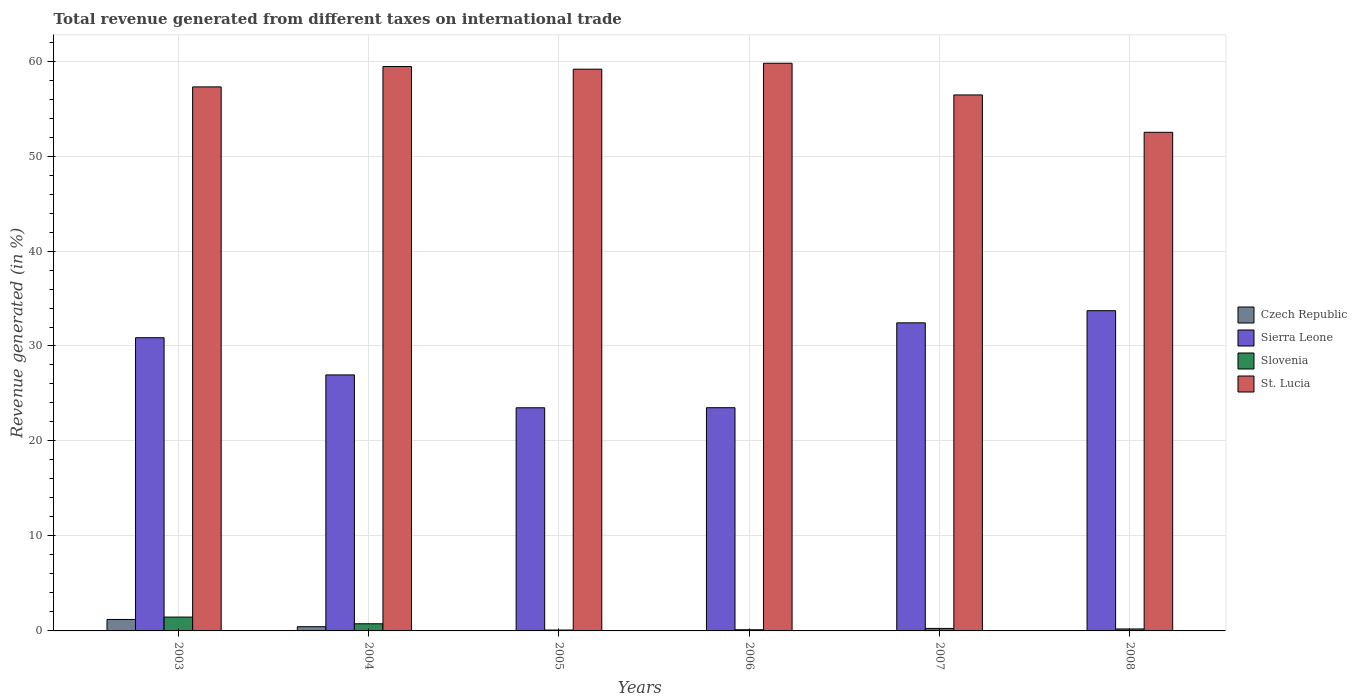Are the number of bars per tick equal to the number of legend labels?
Provide a short and direct response. No. What is the total revenue generated in Sierra Leone in 2006?
Ensure brevity in your answer.  23.5. Across all years, what is the maximum total revenue generated in Slovenia?
Keep it short and to the point. 1.46. In which year was the total revenue generated in Sierra Leone maximum?
Your response must be concise. 2008. What is the total total revenue generated in Slovenia in the graph?
Make the answer very short. 2.9. What is the difference between the total revenue generated in St. Lucia in 2004 and that in 2008?
Ensure brevity in your answer.  6.92. What is the difference between the total revenue generated in Sierra Leone in 2008 and the total revenue generated in Czech Republic in 2003?
Your answer should be very brief. 32.51. What is the average total revenue generated in Czech Republic per year?
Your answer should be compact. 0.28. In the year 2008, what is the difference between the total revenue generated in Sierra Leone and total revenue generated in Slovenia?
Give a very brief answer. 33.51. In how many years, is the total revenue generated in Czech Republic greater than 46 %?
Provide a short and direct response. 0. What is the ratio of the total revenue generated in St. Lucia in 2004 to that in 2005?
Provide a short and direct response. 1. Is the total revenue generated in Slovenia in 2003 less than that in 2006?
Your response must be concise. No. Is the difference between the total revenue generated in Sierra Leone in 2003 and 2004 greater than the difference between the total revenue generated in Slovenia in 2003 and 2004?
Your answer should be very brief. Yes. What is the difference between the highest and the second highest total revenue generated in Sierra Leone?
Ensure brevity in your answer.  1.28. What is the difference between the highest and the lowest total revenue generated in Slovenia?
Give a very brief answer. 1.36. Is the sum of the total revenue generated in Sierra Leone in 2003 and 2006 greater than the maximum total revenue generated in Czech Republic across all years?
Your answer should be compact. Yes. Is it the case that in every year, the sum of the total revenue generated in St. Lucia and total revenue generated in Slovenia is greater than the sum of total revenue generated in Sierra Leone and total revenue generated in Czech Republic?
Offer a terse response. Yes. Is it the case that in every year, the sum of the total revenue generated in St. Lucia and total revenue generated in Sierra Leone is greater than the total revenue generated in Czech Republic?
Give a very brief answer. Yes. How many years are there in the graph?
Ensure brevity in your answer.  6. Does the graph contain any zero values?
Keep it short and to the point. Yes. Does the graph contain grids?
Keep it short and to the point. Yes. What is the title of the graph?
Ensure brevity in your answer.  Total revenue generated from different taxes on international trade. Does "Tonga" appear as one of the legend labels in the graph?
Make the answer very short. No. What is the label or title of the X-axis?
Your answer should be very brief. Years. What is the label or title of the Y-axis?
Make the answer very short. Revenue generated (in %). What is the Revenue generated (in %) of Czech Republic in 2003?
Ensure brevity in your answer.  1.21. What is the Revenue generated (in %) in Sierra Leone in 2003?
Provide a succinct answer. 30.87. What is the Revenue generated (in %) of Slovenia in 2003?
Your response must be concise. 1.46. What is the Revenue generated (in %) in St. Lucia in 2003?
Make the answer very short. 57.28. What is the Revenue generated (in %) of Czech Republic in 2004?
Your answer should be compact. 0.45. What is the Revenue generated (in %) of Sierra Leone in 2004?
Offer a very short reply. 26.96. What is the Revenue generated (in %) in Slovenia in 2004?
Give a very brief answer. 0.75. What is the Revenue generated (in %) of St. Lucia in 2004?
Provide a succinct answer. 59.42. What is the Revenue generated (in %) in Czech Republic in 2005?
Provide a succinct answer. 0. What is the Revenue generated (in %) in Sierra Leone in 2005?
Give a very brief answer. 23.5. What is the Revenue generated (in %) in Slovenia in 2005?
Give a very brief answer. 0.09. What is the Revenue generated (in %) in St. Lucia in 2005?
Offer a terse response. 59.15. What is the Revenue generated (in %) in Czech Republic in 2006?
Your answer should be compact. 0. What is the Revenue generated (in %) of Sierra Leone in 2006?
Offer a very short reply. 23.5. What is the Revenue generated (in %) of Slovenia in 2006?
Provide a short and direct response. 0.12. What is the Revenue generated (in %) in St. Lucia in 2006?
Offer a terse response. 59.77. What is the Revenue generated (in %) in Czech Republic in 2007?
Give a very brief answer. 0. What is the Revenue generated (in %) of Sierra Leone in 2007?
Ensure brevity in your answer.  32.44. What is the Revenue generated (in %) of Slovenia in 2007?
Your response must be concise. 0.26. What is the Revenue generated (in %) in St. Lucia in 2007?
Keep it short and to the point. 56.43. What is the Revenue generated (in %) in Czech Republic in 2008?
Make the answer very short. 0. What is the Revenue generated (in %) in Sierra Leone in 2008?
Give a very brief answer. 33.72. What is the Revenue generated (in %) of Slovenia in 2008?
Give a very brief answer. 0.21. What is the Revenue generated (in %) of St. Lucia in 2008?
Give a very brief answer. 52.5. Across all years, what is the maximum Revenue generated (in %) of Czech Republic?
Offer a very short reply. 1.21. Across all years, what is the maximum Revenue generated (in %) in Sierra Leone?
Your answer should be compact. 33.72. Across all years, what is the maximum Revenue generated (in %) of Slovenia?
Make the answer very short. 1.46. Across all years, what is the maximum Revenue generated (in %) of St. Lucia?
Provide a succinct answer. 59.77. Across all years, what is the minimum Revenue generated (in %) of Czech Republic?
Your answer should be very brief. 0. Across all years, what is the minimum Revenue generated (in %) in Sierra Leone?
Ensure brevity in your answer.  23.5. Across all years, what is the minimum Revenue generated (in %) of Slovenia?
Offer a very short reply. 0.09. Across all years, what is the minimum Revenue generated (in %) in St. Lucia?
Your response must be concise. 52.5. What is the total Revenue generated (in %) of Czech Republic in the graph?
Your answer should be very brief. 1.66. What is the total Revenue generated (in %) in Sierra Leone in the graph?
Offer a very short reply. 170.98. What is the total Revenue generated (in %) of Slovenia in the graph?
Give a very brief answer. 2.9. What is the total Revenue generated (in %) in St. Lucia in the graph?
Ensure brevity in your answer.  344.55. What is the difference between the Revenue generated (in %) in Czech Republic in 2003 and that in 2004?
Give a very brief answer. 0.76. What is the difference between the Revenue generated (in %) of Sierra Leone in 2003 and that in 2004?
Keep it short and to the point. 3.92. What is the difference between the Revenue generated (in %) in Slovenia in 2003 and that in 2004?
Give a very brief answer. 0.7. What is the difference between the Revenue generated (in %) in St. Lucia in 2003 and that in 2004?
Offer a terse response. -2.14. What is the difference between the Revenue generated (in %) of Sierra Leone in 2003 and that in 2005?
Offer a terse response. 7.38. What is the difference between the Revenue generated (in %) in Slovenia in 2003 and that in 2005?
Offer a very short reply. 1.36. What is the difference between the Revenue generated (in %) of St. Lucia in 2003 and that in 2005?
Offer a very short reply. -1.87. What is the difference between the Revenue generated (in %) in Czech Republic in 2003 and that in 2006?
Make the answer very short. 1.21. What is the difference between the Revenue generated (in %) in Sierra Leone in 2003 and that in 2006?
Offer a terse response. 7.37. What is the difference between the Revenue generated (in %) of Slovenia in 2003 and that in 2006?
Keep it short and to the point. 1.33. What is the difference between the Revenue generated (in %) in St. Lucia in 2003 and that in 2006?
Your answer should be very brief. -2.49. What is the difference between the Revenue generated (in %) of Czech Republic in 2003 and that in 2007?
Provide a short and direct response. 1.21. What is the difference between the Revenue generated (in %) of Sierra Leone in 2003 and that in 2007?
Offer a terse response. -1.57. What is the difference between the Revenue generated (in %) in Slovenia in 2003 and that in 2007?
Your answer should be compact. 1.19. What is the difference between the Revenue generated (in %) of St. Lucia in 2003 and that in 2007?
Keep it short and to the point. 0.85. What is the difference between the Revenue generated (in %) in Czech Republic in 2003 and that in 2008?
Your answer should be very brief. 1.21. What is the difference between the Revenue generated (in %) of Sierra Leone in 2003 and that in 2008?
Offer a very short reply. -2.85. What is the difference between the Revenue generated (in %) of Slovenia in 2003 and that in 2008?
Provide a short and direct response. 1.25. What is the difference between the Revenue generated (in %) of St. Lucia in 2003 and that in 2008?
Your answer should be very brief. 4.78. What is the difference between the Revenue generated (in %) of Sierra Leone in 2004 and that in 2005?
Ensure brevity in your answer.  3.46. What is the difference between the Revenue generated (in %) of Slovenia in 2004 and that in 2005?
Your answer should be compact. 0.66. What is the difference between the Revenue generated (in %) of St. Lucia in 2004 and that in 2005?
Ensure brevity in your answer.  0.28. What is the difference between the Revenue generated (in %) of Czech Republic in 2004 and that in 2006?
Make the answer very short. 0.44. What is the difference between the Revenue generated (in %) in Sierra Leone in 2004 and that in 2006?
Your response must be concise. 3.45. What is the difference between the Revenue generated (in %) in Slovenia in 2004 and that in 2006?
Make the answer very short. 0.63. What is the difference between the Revenue generated (in %) of St. Lucia in 2004 and that in 2006?
Give a very brief answer. -0.35. What is the difference between the Revenue generated (in %) of Czech Republic in 2004 and that in 2007?
Make the answer very short. 0.44. What is the difference between the Revenue generated (in %) of Sierra Leone in 2004 and that in 2007?
Offer a terse response. -5.48. What is the difference between the Revenue generated (in %) of Slovenia in 2004 and that in 2007?
Provide a short and direct response. 0.49. What is the difference between the Revenue generated (in %) in St. Lucia in 2004 and that in 2007?
Provide a short and direct response. 2.99. What is the difference between the Revenue generated (in %) in Czech Republic in 2004 and that in 2008?
Provide a short and direct response. 0.44. What is the difference between the Revenue generated (in %) of Sierra Leone in 2004 and that in 2008?
Your response must be concise. -6.76. What is the difference between the Revenue generated (in %) of Slovenia in 2004 and that in 2008?
Keep it short and to the point. 0.55. What is the difference between the Revenue generated (in %) of St. Lucia in 2004 and that in 2008?
Your answer should be very brief. 6.92. What is the difference between the Revenue generated (in %) in Sierra Leone in 2005 and that in 2006?
Keep it short and to the point. -0.01. What is the difference between the Revenue generated (in %) in Slovenia in 2005 and that in 2006?
Your answer should be compact. -0.03. What is the difference between the Revenue generated (in %) in St. Lucia in 2005 and that in 2006?
Your answer should be very brief. -0.62. What is the difference between the Revenue generated (in %) in Sierra Leone in 2005 and that in 2007?
Offer a terse response. -8.94. What is the difference between the Revenue generated (in %) of Slovenia in 2005 and that in 2007?
Ensure brevity in your answer.  -0.17. What is the difference between the Revenue generated (in %) in St. Lucia in 2005 and that in 2007?
Provide a succinct answer. 2.71. What is the difference between the Revenue generated (in %) of Sierra Leone in 2005 and that in 2008?
Provide a succinct answer. -10.22. What is the difference between the Revenue generated (in %) in Slovenia in 2005 and that in 2008?
Make the answer very short. -0.11. What is the difference between the Revenue generated (in %) in St. Lucia in 2005 and that in 2008?
Your response must be concise. 6.65. What is the difference between the Revenue generated (in %) in Czech Republic in 2006 and that in 2007?
Ensure brevity in your answer.  -0. What is the difference between the Revenue generated (in %) of Sierra Leone in 2006 and that in 2007?
Provide a succinct answer. -8.94. What is the difference between the Revenue generated (in %) in Slovenia in 2006 and that in 2007?
Your response must be concise. -0.14. What is the difference between the Revenue generated (in %) in St. Lucia in 2006 and that in 2007?
Provide a short and direct response. 3.34. What is the difference between the Revenue generated (in %) in Czech Republic in 2006 and that in 2008?
Ensure brevity in your answer.  -0. What is the difference between the Revenue generated (in %) in Sierra Leone in 2006 and that in 2008?
Keep it short and to the point. -10.21. What is the difference between the Revenue generated (in %) in Slovenia in 2006 and that in 2008?
Give a very brief answer. -0.08. What is the difference between the Revenue generated (in %) of St. Lucia in 2006 and that in 2008?
Provide a short and direct response. 7.27. What is the difference between the Revenue generated (in %) of Czech Republic in 2007 and that in 2008?
Offer a terse response. 0. What is the difference between the Revenue generated (in %) of Sierra Leone in 2007 and that in 2008?
Your answer should be compact. -1.28. What is the difference between the Revenue generated (in %) in Slovenia in 2007 and that in 2008?
Make the answer very short. 0.06. What is the difference between the Revenue generated (in %) in St. Lucia in 2007 and that in 2008?
Offer a terse response. 3.93. What is the difference between the Revenue generated (in %) of Czech Republic in 2003 and the Revenue generated (in %) of Sierra Leone in 2004?
Provide a short and direct response. -25.75. What is the difference between the Revenue generated (in %) in Czech Republic in 2003 and the Revenue generated (in %) in Slovenia in 2004?
Make the answer very short. 0.45. What is the difference between the Revenue generated (in %) of Czech Republic in 2003 and the Revenue generated (in %) of St. Lucia in 2004?
Your response must be concise. -58.22. What is the difference between the Revenue generated (in %) of Sierra Leone in 2003 and the Revenue generated (in %) of Slovenia in 2004?
Your answer should be compact. 30.12. What is the difference between the Revenue generated (in %) in Sierra Leone in 2003 and the Revenue generated (in %) in St. Lucia in 2004?
Your answer should be very brief. -28.55. What is the difference between the Revenue generated (in %) in Slovenia in 2003 and the Revenue generated (in %) in St. Lucia in 2004?
Your answer should be very brief. -57.96. What is the difference between the Revenue generated (in %) of Czech Republic in 2003 and the Revenue generated (in %) of Sierra Leone in 2005?
Your answer should be very brief. -22.29. What is the difference between the Revenue generated (in %) in Czech Republic in 2003 and the Revenue generated (in %) in Slovenia in 2005?
Your answer should be very brief. 1.11. What is the difference between the Revenue generated (in %) in Czech Republic in 2003 and the Revenue generated (in %) in St. Lucia in 2005?
Your answer should be very brief. -57.94. What is the difference between the Revenue generated (in %) in Sierra Leone in 2003 and the Revenue generated (in %) in Slovenia in 2005?
Make the answer very short. 30.78. What is the difference between the Revenue generated (in %) of Sierra Leone in 2003 and the Revenue generated (in %) of St. Lucia in 2005?
Keep it short and to the point. -28.28. What is the difference between the Revenue generated (in %) in Slovenia in 2003 and the Revenue generated (in %) in St. Lucia in 2005?
Your response must be concise. -57.69. What is the difference between the Revenue generated (in %) in Czech Republic in 2003 and the Revenue generated (in %) in Sierra Leone in 2006?
Offer a very short reply. -22.3. What is the difference between the Revenue generated (in %) in Czech Republic in 2003 and the Revenue generated (in %) in Slovenia in 2006?
Ensure brevity in your answer.  1.08. What is the difference between the Revenue generated (in %) of Czech Republic in 2003 and the Revenue generated (in %) of St. Lucia in 2006?
Provide a short and direct response. -58.56. What is the difference between the Revenue generated (in %) in Sierra Leone in 2003 and the Revenue generated (in %) in Slovenia in 2006?
Your answer should be compact. 30.75. What is the difference between the Revenue generated (in %) of Sierra Leone in 2003 and the Revenue generated (in %) of St. Lucia in 2006?
Your response must be concise. -28.9. What is the difference between the Revenue generated (in %) of Slovenia in 2003 and the Revenue generated (in %) of St. Lucia in 2006?
Provide a succinct answer. -58.31. What is the difference between the Revenue generated (in %) in Czech Republic in 2003 and the Revenue generated (in %) in Sierra Leone in 2007?
Your answer should be very brief. -31.23. What is the difference between the Revenue generated (in %) in Czech Republic in 2003 and the Revenue generated (in %) in Slovenia in 2007?
Offer a very short reply. 0.94. What is the difference between the Revenue generated (in %) of Czech Republic in 2003 and the Revenue generated (in %) of St. Lucia in 2007?
Provide a succinct answer. -55.23. What is the difference between the Revenue generated (in %) in Sierra Leone in 2003 and the Revenue generated (in %) in Slovenia in 2007?
Ensure brevity in your answer.  30.61. What is the difference between the Revenue generated (in %) in Sierra Leone in 2003 and the Revenue generated (in %) in St. Lucia in 2007?
Give a very brief answer. -25.56. What is the difference between the Revenue generated (in %) of Slovenia in 2003 and the Revenue generated (in %) of St. Lucia in 2007?
Keep it short and to the point. -54.98. What is the difference between the Revenue generated (in %) in Czech Republic in 2003 and the Revenue generated (in %) in Sierra Leone in 2008?
Provide a succinct answer. -32.51. What is the difference between the Revenue generated (in %) of Czech Republic in 2003 and the Revenue generated (in %) of Slovenia in 2008?
Your answer should be very brief. 1. What is the difference between the Revenue generated (in %) in Czech Republic in 2003 and the Revenue generated (in %) in St. Lucia in 2008?
Offer a terse response. -51.29. What is the difference between the Revenue generated (in %) of Sierra Leone in 2003 and the Revenue generated (in %) of Slovenia in 2008?
Make the answer very short. 30.66. What is the difference between the Revenue generated (in %) of Sierra Leone in 2003 and the Revenue generated (in %) of St. Lucia in 2008?
Your answer should be very brief. -21.63. What is the difference between the Revenue generated (in %) of Slovenia in 2003 and the Revenue generated (in %) of St. Lucia in 2008?
Your response must be concise. -51.04. What is the difference between the Revenue generated (in %) in Czech Republic in 2004 and the Revenue generated (in %) in Sierra Leone in 2005?
Give a very brief answer. -23.05. What is the difference between the Revenue generated (in %) of Czech Republic in 2004 and the Revenue generated (in %) of Slovenia in 2005?
Offer a very short reply. 0.35. What is the difference between the Revenue generated (in %) of Czech Republic in 2004 and the Revenue generated (in %) of St. Lucia in 2005?
Your answer should be very brief. -58.7. What is the difference between the Revenue generated (in %) of Sierra Leone in 2004 and the Revenue generated (in %) of Slovenia in 2005?
Make the answer very short. 26.86. What is the difference between the Revenue generated (in %) of Sierra Leone in 2004 and the Revenue generated (in %) of St. Lucia in 2005?
Your answer should be compact. -32.19. What is the difference between the Revenue generated (in %) in Slovenia in 2004 and the Revenue generated (in %) in St. Lucia in 2005?
Give a very brief answer. -58.39. What is the difference between the Revenue generated (in %) in Czech Republic in 2004 and the Revenue generated (in %) in Sierra Leone in 2006?
Your response must be concise. -23.06. What is the difference between the Revenue generated (in %) of Czech Republic in 2004 and the Revenue generated (in %) of Slovenia in 2006?
Keep it short and to the point. 0.32. What is the difference between the Revenue generated (in %) of Czech Republic in 2004 and the Revenue generated (in %) of St. Lucia in 2006?
Provide a short and direct response. -59.32. What is the difference between the Revenue generated (in %) of Sierra Leone in 2004 and the Revenue generated (in %) of Slovenia in 2006?
Offer a terse response. 26.83. What is the difference between the Revenue generated (in %) of Sierra Leone in 2004 and the Revenue generated (in %) of St. Lucia in 2006?
Provide a short and direct response. -32.81. What is the difference between the Revenue generated (in %) in Slovenia in 2004 and the Revenue generated (in %) in St. Lucia in 2006?
Your response must be concise. -59.02. What is the difference between the Revenue generated (in %) of Czech Republic in 2004 and the Revenue generated (in %) of Sierra Leone in 2007?
Your answer should be compact. -31.99. What is the difference between the Revenue generated (in %) in Czech Republic in 2004 and the Revenue generated (in %) in Slovenia in 2007?
Make the answer very short. 0.18. What is the difference between the Revenue generated (in %) in Czech Republic in 2004 and the Revenue generated (in %) in St. Lucia in 2007?
Your response must be concise. -55.99. What is the difference between the Revenue generated (in %) in Sierra Leone in 2004 and the Revenue generated (in %) in Slovenia in 2007?
Your answer should be compact. 26.69. What is the difference between the Revenue generated (in %) of Sierra Leone in 2004 and the Revenue generated (in %) of St. Lucia in 2007?
Your answer should be compact. -29.48. What is the difference between the Revenue generated (in %) of Slovenia in 2004 and the Revenue generated (in %) of St. Lucia in 2007?
Your answer should be very brief. -55.68. What is the difference between the Revenue generated (in %) in Czech Republic in 2004 and the Revenue generated (in %) in Sierra Leone in 2008?
Ensure brevity in your answer.  -33.27. What is the difference between the Revenue generated (in %) of Czech Republic in 2004 and the Revenue generated (in %) of Slovenia in 2008?
Offer a terse response. 0.24. What is the difference between the Revenue generated (in %) in Czech Republic in 2004 and the Revenue generated (in %) in St. Lucia in 2008?
Keep it short and to the point. -52.05. What is the difference between the Revenue generated (in %) of Sierra Leone in 2004 and the Revenue generated (in %) of Slovenia in 2008?
Keep it short and to the point. 26.75. What is the difference between the Revenue generated (in %) in Sierra Leone in 2004 and the Revenue generated (in %) in St. Lucia in 2008?
Give a very brief answer. -25.55. What is the difference between the Revenue generated (in %) in Slovenia in 2004 and the Revenue generated (in %) in St. Lucia in 2008?
Ensure brevity in your answer.  -51.75. What is the difference between the Revenue generated (in %) of Sierra Leone in 2005 and the Revenue generated (in %) of Slovenia in 2006?
Offer a terse response. 23.37. What is the difference between the Revenue generated (in %) of Sierra Leone in 2005 and the Revenue generated (in %) of St. Lucia in 2006?
Provide a succinct answer. -36.27. What is the difference between the Revenue generated (in %) of Slovenia in 2005 and the Revenue generated (in %) of St. Lucia in 2006?
Your response must be concise. -59.68. What is the difference between the Revenue generated (in %) in Sierra Leone in 2005 and the Revenue generated (in %) in Slovenia in 2007?
Make the answer very short. 23.23. What is the difference between the Revenue generated (in %) of Sierra Leone in 2005 and the Revenue generated (in %) of St. Lucia in 2007?
Your response must be concise. -32.94. What is the difference between the Revenue generated (in %) in Slovenia in 2005 and the Revenue generated (in %) in St. Lucia in 2007?
Ensure brevity in your answer.  -56.34. What is the difference between the Revenue generated (in %) of Sierra Leone in 2005 and the Revenue generated (in %) of Slovenia in 2008?
Your response must be concise. 23.29. What is the difference between the Revenue generated (in %) in Sierra Leone in 2005 and the Revenue generated (in %) in St. Lucia in 2008?
Offer a very short reply. -29. What is the difference between the Revenue generated (in %) in Slovenia in 2005 and the Revenue generated (in %) in St. Lucia in 2008?
Give a very brief answer. -52.41. What is the difference between the Revenue generated (in %) in Czech Republic in 2006 and the Revenue generated (in %) in Sierra Leone in 2007?
Your answer should be compact. -32.44. What is the difference between the Revenue generated (in %) in Czech Republic in 2006 and the Revenue generated (in %) in Slovenia in 2007?
Provide a short and direct response. -0.26. What is the difference between the Revenue generated (in %) of Czech Republic in 2006 and the Revenue generated (in %) of St. Lucia in 2007?
Your response must be concise. -56.43. What is the difference between the Revenue generated (in %) in Sierra Leone in 2006 and the Revenue generated (in %) in Slovenia in 2007?
Ensure brevity in your answer.  23.24. What is the difference between the Revenue generated (in %) in Sierra Leone in 2006 and the Revenue generated (in %) in St. Lucia in 2007?
Your answer should be compact. -32.93. What is the difference between the Revenue generated (in %) in Slovenia in 2006 and the Revenue generated (in %) in St. Lucia in 2007?
Provide a short and direct response. -56.31. What is the difference between the Revenue generated (in %) in Czech Republic in 2006 and the Revenue generated (in %) in Sierra Leone in 2008?
Ensure brevity in your answer.  -33.72. What is the difference between the Revenue generated (in %) in Czech Republic in 2006 and the Revenue generated (in %) in Slovenia in 2008?
Keep it short and to the point. -0.21. What is the difference between the Revenue generated (in %) in Czech Republic in 2006 and the Revenue generated (in %) in St. Lucia in 2008?
Offer a very short reply. -52.5. What is the difference between the Revenue generated (in %) of Sierra Leone in 2006 and the Revenue generated (in %) of Slovenia in 2008?
Ensure brevity in your answer.  23.3. What is the difference between the Revenue generated (in %) in Sierra Leone in 2006 and the Revenue generated (in %) in St. Lucia in 2008?
Give a very brief answer. -29. What is the difference between the Revenue generated (in %) of Slovenia in 2006 and the Revenue generated (in %) of St. Lucia in 2008?
Provide a short and direct response. -52.38. What is the difference between the Revenue generated (in %) of Czech Republic in 2007 and the Revenue generated (in %) of Sierra Leone in 2008?
Your response must be concise. -33.71. What is the difference between the Revenue generated (in %) of Czech Republic in 2007 and the Revenue generated (in %) of Slovenia in 2008?
Your response must be concise. -0.21. What is the difference between the Revenue generated (in %) of Czech Republic in 2007 and the Revenue generated (in %) of St. Lucia in 2008?
Your response must be concise. -52.5. What is the difference between the Revenue generated (in %) of Sierra Leone in 2007 and the Revenue generated (in %) of Slovenia in 2008?
Give a very brief answer. 32.23. What is the difference between the Revenue generated (in %) in Sierra Leone in 2007 and the Revenue generated (in %) in St. Lucia in 2008?
Your answer should be compact. -20.06. What is the difference between the Revenue generated (in %) in Slovenia in 2007 and the Revenue generated (in %) in St. Lucia in 2008?
Offer a terse response. -52.24. What is the average Revenue generated (in %) in Czech Republic per year?
Give a very brief answer. 0.28. What is the average Revenue generated (in %) of Sierra Leone per year?
Give a very brief answer. 28.5. What is the average Revenue generated (in %) of Slovenia per year?
Offer a terse response. 0.48. What is the average Revenue generated (in %) in St. Lucia per year?
Provide a short and direct response. 57.43. In the year 2003, what is the difference between the Revenue generated (in %) in Czech Republic and Revenue generated (in %) in Sierra Leone?
Ensure brevity in your answer.  -29.66. In the year 2003, what is the difference between the Revenue generated (in %) of Czech Republic and Revenue generated (in %) of Slovenia?
Your answer should be very brief. -0.25. In the year 2003, what is the difference between the Revenue generated (in %) of Czech Republic and Revenue generated (in %) of St. Lucia?
Provide a succinct answer. -56.07. In the year 2003, what is the difference between the Revenue generated (in %) of Sierra Leone and Revenue generated (in %) of Slovenia?
Your response must be concise. 29.41. In the year 2003, what is the difference between the Revenue generated (in %) of Sierra Leone and Revenue generated (in %) of St. Lucia?
Provide a short and direct response. -26.41. In the year 2003, what is the difference between the Revenue generated (in %) of Slovenia and Revenue generated (in %) of St. Lucia?
Offer a terse response. -55.82. In the year 2004, what is the difference between the Revenue generated (in %) of Czech Republic and Revenue generated (in %) of Sierra Leone?
Make the answer very short. -26.51. In the year 2004, what is the difference between the Revenue generated (in %) in Czech Republic and Revenue generated (in %) in Slovenia?
Provide a succinct answer. -0.31. In the year 2004, what is the difference between the Revenue generated (in %) of Czech Republic and Revenue generated (in %) of St. Lucia?
Offer a very short reply. -58.98. In the year 2004, what is the difference between the Revenue generated (in %) in Sierra Leone and Revenue generated (in %) in Slovenia?
Your response must be concise. 26.2. In the year 2004, what is the difference between the Revenue generated (in %) of Sierra Leone and Revenue generated (in %) of St. Lucia?
Your answer should be very brief. -32.47. In the year 2004, what is the difference between the Revenue generated (in %) in Slovenia and Revenue generated (in %) in St. Lucia?
Offer a terse response. -58.67. In the year 2005, what is the difference between the Revenue generated (in %) in Sierra Leone and Revenue generated (in %) in Slovenia?
Ensure brevity in your answer.  23.4. In the year 2005, what is the difference between the Revenue generated (in %) in Sierra Leone and Revenue generated (in %) in St. Lucia?
Offer a terse response. -35.65. In the year 2005, what is the difference between the Revenue generated (in %) in Slovenia and Revenue generated (in %) in St. Lucia?
Your response must be concise. -59.05. In the year 2006, what is the difference between the Revenue generated (in %) in Czech Republic and Revenue generated (in %) in Sierra Leone?
Ensure brevity in your answer.  -23.5. In the year 2006, what is the difference between the Revenue generated (in %) of Czech Republic and Revenue generated (in %) of Slovenia?
Ensure brevity in your answer.  -0.12. In the year 2006, what is the difference between the Revenue generated (in %) of Czech Republic and Revenue generated (in %) of St. Lucia?
Your answer should be compact. -59.77. In the year 2006, what is the difference between the Revenue generated (in %) of Sierra Leone and Revenue generated (in %) of Slovenia?
Provide a succinct answer. 23.38. In the year 2006, what is the difference between the Revenue generated (in %) in Sierra Leone and Revenue generated (in %) in St. Lucia?
Ensure brevity in your answer.  -36.27. In the year 2006, what is the difference between the Revenue generated (in %) in Slovenia and Revenue generated (in %) in St. Lucia?
Give a very brief answer. -59.65. In the year 2007, what is the difference between the Revenue generated (in %) in Czech Republic and Revenue generated (in %) in Sierra Leone?
Provide a succinct answer. -32.44. In the year 2007, what is the difference between the Revenue generated (in %) in Czech Republic and Revenue generated (in %) in Slovenia?
Offer a very short reply. -0.26. In the year 2007, what is the difference between the Revenue generated (in %) of Czech Republic and Revenue generated (in %) of St. Lucia?
Ensure brevity in your answer.  -56.43. In the year 2007, what is the difference between the Revenue generated (in %) in Sierra Leone and Revenue generated (in %) in Slovenia?
Offer a very short reply. 32.17. In the year 2007, what is the difference between the Revenue generated (in %) of Sierra Leone and Revenue generated (in %) of St. Lucia?
Your answer should be very brief. -24. In the year 2007, what is the difference between the Revenue generated (in %) of Slovenia and Revenue generated (in %) of St. Lucia?
Keep it short and to the point. -56.17. In the year 2008, what is the difference between the Revenue generated (in %) in Czech Republic and Revenue generated (in %) in Sierra Leone?
Keep it short and to the point. -33.72. In the year 2008, what is the difference between the Revenue generated (in %) of Czech Republic and Revenue generated (in %) of Slovenia?
Offer a very short reply. -0.21. In the year 2008, what is the difference between the Revenue generated (in %) of Czech Republic and Revenue generated (in %) of St. Lucia?
Provide a short and direct response. -52.5. In the year 2008, what is the difference between the Revenue generated (in %) of Sierra Leone and Revenue generated (in %) of Slovenia?
Your answer should be very brief. 33.51. In the year 2008, what is the difference between the Revenue generated (in %) of Sierra Leone and Revenue generated (in %) of St. Lucia?
Provide a short and direct response. -18.78. In the year 2008, what is the difference between the Revenue generated (in %) in Slovenia and Revenue generated (in %) in St. Lucia?
Make the answer very short. -52.29. What is the ratio of the Revenue generated (in %) of Czech Republic in 2003 to that in 2004?
Provide a short and direct response. 2.71. What is the ratio of the Revenue generated (in %) in Sierra Leone in 2003 to that in 2004?
Keep it short and to the point. 1.15. What is the ratio of the Revenue generated (in %) of Slovenia in 2003 to that in 2004?
Ensure brevity in your answer.  1.94. What is the ratio of the Revenue generated (in %) in St. Lucia in 2003 to that in 2004?
Your response must be concise. 0.96. What is the ratio of the Revenue generated (in %) of Sierra Leone in 2003 to that in 2005?
Your answer should be very brief. 1.31. What is the ratio of the Revenue generated (in %) in Slovenia in 2003 to that in 2005?
Keep it short and to the point. 15.63. What is the ratio of the Revenue generated (in %) of St. Lucia in 2003 to that in 2005?
Provide a short and direct response. 0.97. What is the ratio of the Revenue generated (in %) in Czech Republic in 2003 to that in 2006?
Your answer should be very brief. 2067.86. What is the ratio of the Revenue generated (in %) in Sierra Leone in 2003 to that in 2006?
Make the answer very short. 1.31. What is the ratio of the Revenue generated (in %) of Slovenia in 2003 to that in 2006?
Ensure brevity in your answer.  11.82. What is the ratio of the Revenue generated (in %) in St. Lucia in 2003 to that in 2006?
Give a very brief answer. 0.96. What is the ratio of the Revenue generated (in %) in Czech Republic in 2003 to that in 2007?
Offer a terse response. 581.21. What is the ratio of the Revenue generated (in %) in Sierra Leone in 2003 to that in 2007?
Offer a very short reply. 0.95. What is the ratio of the Revenue generated (in %) of Slovenia in 2003 to that in 2007?
Offer a terse response. 5.52. What is the ratio of the Revenue generated (in %) in Czech Republic in 2003 to that in 2008?
Give a very brief answer. 1841.91. What is the ratio of the Revenue generated (in %) of Sierra Leone in 2003 to that in 2008?
Give a very brief answer. 0.92. What is the ratio of the Revenue generated (in %) in Slovenia in 2003 to that in 2008?
Provide a short and direct response. 7.04. What is the ratio of the Revenue generated (in %) in St. Lucia in 2003 to that in 2008?
Provide a short and direct response. 1.09. What is the ratio of the Revenue generated (in %) of Sierra Leone in 2004 to that in 2005?
Your answer should be very brief. 1.15. What is the ratio of the Revenue generated (in %) in Slovenia in 2004 to that in 2005?
Your response must be concise. 8.07. What is the ratio of the Revenue generated (in %) of St. Lucia in 2004 to that in 2005?
Ensure brevity in your answer.  1. What is the ratio of the Revenue generated (in %) of Czech Republic in 2004 to that in 2006?
Your answer should be very brief. 763.23. What is the ratio of the Revenue generated (in %) of Sierra Leone in 2004 to that in 2006?
Ensure brevity in your answer.  1.15. What is the ratio of the Revenue generated (in %) of Slovenia in 2004 to that in 2006?
Provide a short and direct response. 6.11. What is the ratio of the Revenue generated (in %) of Czech Republic in 2004 to that in 2007?
Keep it short and to the point. 214.52. What is the ratio of the Revenue generated (in %) of Sierra Leone in 2004 to that in 2007?
Offer a very short reply. 0.83. What is the ratio of the Revenue generated (in %) of Slovenia in 2004 to that in 2007?
Your answer should be very brief. 2.85. What is the ratio of the Revenue generated (in %) in St. Lucia in 2004 to that in 2007?
Make the answer very short. 1.05. What is the ratio of the Revenue generated (in %) in Czech Republic in 2004 to that in 2008?
Offer a terse response. 679.83. What is the ratio of the Revenue generated (in %) in Sierra Leone in 2004 to that in 2008?
Provide a succinct answer. 0.8. What is the ratio of the Revenue generated (in %) in Slovenia in 2004 to that in 2008?
Keep it short and to the point. 3.64. What is the ratio of the Revenue generated (in %) of St. Lucia in 2004 to that in 2008?
Give a very brief answer. 1.13. What is the ratio of the Revenue generated (in %) in Sierra Leone in 2005 to that in 2006?
Give a very brief answer. 1. What is the ratio of the Revenue generated (in %) in Slovenia in 2005 to that in 2006?
Your answer should be compact. 0.76. What is the ratio of the Revenue generated (in %) in Sierra Leone in 2005 to that in 2007?
Your answer should be very brief. 0.72. What is the ratio of the Revenue generated (in %) of Slovenia in 2005 to that in 2007?
Your answer should be very brief. 0.35. What is the ratio of the Revenue generated (in %) in St. Lucia in 2005 to that in 2007?
Offer a terse response. 1.05. What is the ratio of the Revenue generated (in %) of Sierra Leone in 2005 to that in 2008?
Your response must be concise. 0.7. What is the ratio of the Revenue generated (in %) of Slovenia in 2005 to that in 2008?
Your answer should be compact. 0.45. What is the ratio of the Revenue generated (in %) of St. Lucia in 2005 to that in 2008?
Offer a terse response. 1.13. What is the ratio of the Revenue generated (in %) of Czech Republic in 2006 to that in 2007?
Offer a very short reply. 0.28. What is the ratio of the Revenue generated (in %) in Sierra Leone in 2006 to that in 2007?
Make the answer very short. 0.72. What is the ratio of the Revenue generated (in %) in Slovenia in 2006 to that in 2007?
Your response must be concise. 0.47. What is the ratio of the Revenue generated (in %) in St. Lucia in 2006 to that in 2007?
Give a very brief answer. 1.06. What is the ratio of the Revenue generated (in %) of Czech Republic in 2006 to that in 2008?
Ensure brevity in your answer.  0.89. What is the ratio of the Revenue generated (in %) in Sierra Leone in 2006 to that in 2008?
Ensure brevity in your answer.  0.7. What is the ratio of the Revenue generated (in %) of Slovenia in 2006 to that in 2008?
Give a very brief answer. 0.6. What is the ratio of the Revenue generated (in %) of St. Lucia in 2006 to that in 2008?
Offer a terse response. 1.14. What is the ratio of the Revenue generated (in %) in Czech Republic in 2007 to that in 2008?
Keep it short and to the point. 3.17. What is the ratio of the Revenue generated (in %) of Sierra Leone in 2007 to that in 2008?
Offer a very short reply. 0.96. What is the ratio of the Revenue generated (in %) of Slovenia in 2007 to that in 2008?
Provide a short and direct response. 1.28. What is the ratio of the Revenue generated (in %) in St. Lucia in 2007 to that in 2008?
Provide a succinct answer. 1.07. What is the difference between the highest and the second highest Revenue generated (in %) in Czech Republic?
Your answer should be compact. 0.76. What is the difference between the highest and the second highest Revenue generated (in %) of Sierra Leone?
Your answer should be compact. 1.28. What is the difference between the highest and the second highest Revenue generated (in %) in Slovenia?
Your answer should be compact. 0.7. What is the difference between the highest and the second highest Revenue generated (in %) of St. Lucia?
Provide a succinct answer. 0.35. What is the difference between the highest and the lowest Revenue generated (in %) of Czech Republic?
Your response must be concise. 1.21. What is the difference between the highest and the lowest Revenue generated (in %) of Sierra Leone?
Offer a very short reply. 10.22. What is the difference between the highest and the lowest Revenue generated (in %) of Slovenia?
Your answer should be very brief. 1.36. What is the difference between the highest and the lowest Revenue generated (in %) of St. Lucia?
Your answer should be compact. 7.27. 